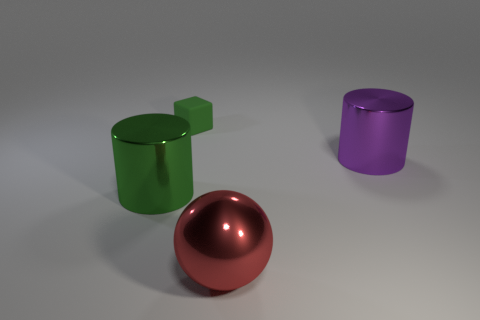Subtract all spheres. How many objects are left? 3 Add 2 small rubber cubes. How many objects exist? 6 Subtract 1 red spheres. How many objects are left? 3 Subtract all big gray shiny cylinders. Subtract all cylinders. How many objects are left? 2 Add 1 big spheres. How many big spheres are left? 2 Add 2 tiny green metallic cylinders. How many tiny green metallic cylinders exist? 2 